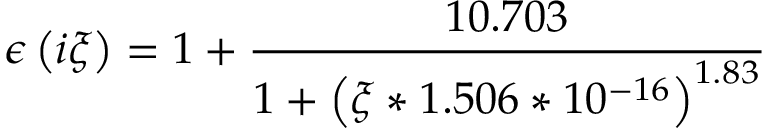<formula> <loc_0><loc_0><loc_500><loc_500>\epsilon \left ( i \xi \right ) = 1 + \frac { 1 0 . 7 0 3 } { 1 + \left ( \xi * 1 . 5 0 6 * 1 0 ^ { - 1 6 } \right ) ^ { 1 . 8 3 } }</formula> 